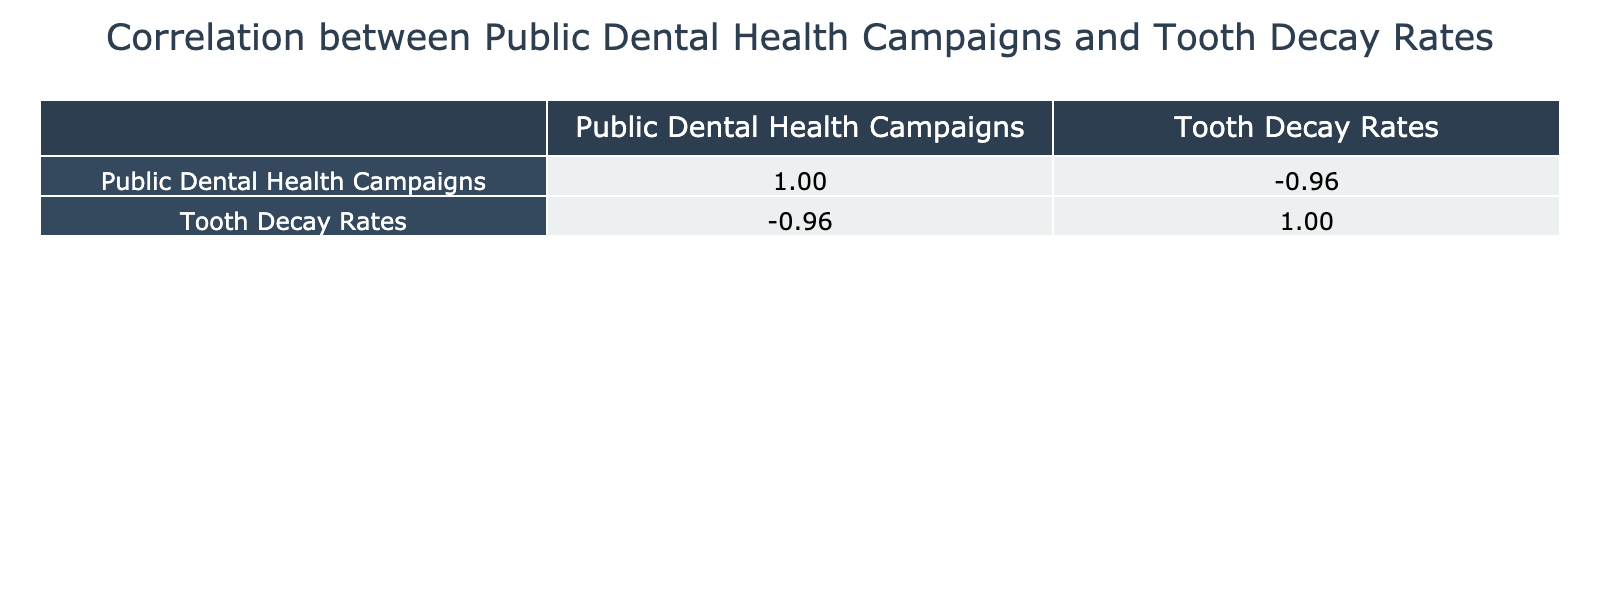What year had the highest public dental health campaigns? In the table, the column for Public Dental Health Campaigns shows the highest value at 2.5 in the year 2020.
Answer: 2020 What were the tooth decay rates in 1990? The table indicates that the tooth decay rate in the year 1990 was 25 per 1000.
Answer: 25 Is there a correlation between public dental health campaigns and tooth decay rates based on the table? Yes, there appears to be a negative correlation, as the table suggests that as the campaigns increase, the decay rates decrease.
Answer: Yes What was the average tooth decay rate between 1950 and 2000? To find the average, sum the tooth decay rates from these years (50 + 45 + 40 + 30 + 25 + 20) which equals 210, and then divide by the 6 years gives 210/6 = 35.
Answer: 35 In which year did tooth decay rates drop below 30 per 1000 for the first time? In the table, tooth decay rates first dropped below 30 in the year 1980 when the rate was 30, and subsequently fell to 25 in 1990.
Answer: 1980 How much did the public dental health campaigns increase from 2000 to 2010? The campaigns in 2000 were at 1.5 and in 2010 were at 2.0. The increase is calculated as 2.0 - 1.5 = 0.5.
Answer: 0.5 Did the notable historical figure change from the 1970s to the 1980s? Yes, in the 1970s it was Dr. Paul Keyes, and in the 1980s, it changed to Dr. Charles W. Smith.
Answer: Yes What is the correlation coefficient between the public dental health campaigns and tooth decay rates? From the correlation table, the correlation coefficient for Public Dental Health Campaigns and Tooth Decay Rates is approximately -1.00, indicating a strong negative correlation.
Answer: -1.00 What were the tooth decay rates in 2000 compared to those in 1980? The data shows that tooth decay rates in 2000 were 20 per 1000, while in 1980 they were 30 per 1000. The difference is 30 - 20 = 10.
Answer: 10 